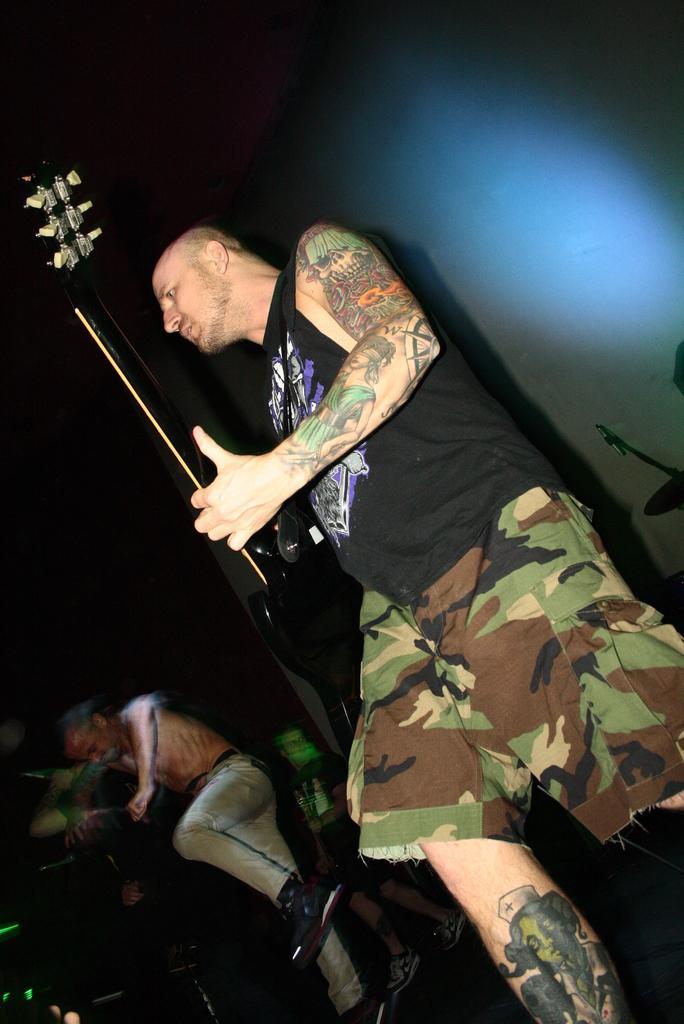In one or two sentences, can you explain what this image depicts? A man black t-shirt is standing and he is playing a guitar. Beside him there are some people standing. 